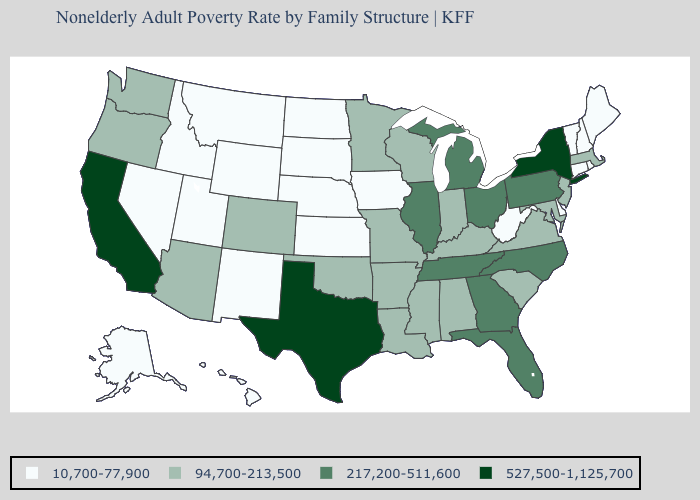Is the legend a continuous bar?
Write a very short answer. No. Name the states that have a value in the range 94,700-213,500?
Give a very brief answer. Alabama, Arizona, Arkansas, Colorado, Indiana, Kentucky, Louisiana, Maryland, Massachusetts, Minnesota, Mississippi, Missouri, New Jersey, Oklahoma, Oregon, South Carolina, Virginia, Washington, Wisconsin. What is the value of Maryland?
Concise answer only. 94,700-213,500. Name the states that have a value in the range 527,500-1,125,700?
Be succinct. California, New York, Texas. Does Arizona have the same value as Texas?
Answer briefly. No. Name the states that have a value in the range 94,700-213,500?
Be succinct. Alabama, Arizona, Arkansas, Colorado, Indiana, Kentucky, Louisiana, Maryland, Massachusetts, Minnesota, Mississippi, Missouri, New Jersey, Oklahoma, Oregon, South Carolina, Virginia, Washington, Wisconsin. What is the value of New Mexico?
Be succinct. 10,700-77,900. Does North Dakota have the same value as New Mexico?
Short answer required. Yes. What is the value of Montana?
Write a very short answer. 10,700-77,900. Name the states that have a value in the range 94,700-213,500?
Keep it brief. Alabama, Arizona, Arkansas, Colorado, Indiana, Kentucky, Louisiana, Maryland, Massachusetts, Minnesota, Mississippi, Missouri, New Jersey, Oklahoma, Oregon, South Carolina, Virginia, Washington, Wisconsin. Among the states that border New Mexico , which have the lowest value?
Be succinct. Utah. Does Nebraska have a lower value than Mississippi?
Give a very brief answer. Yes. Name the states that have a value in the range 527,500-1,125,700?
Give a very brief answer. California, New York, Texas. What is the value of Rhode Island?
Give a very brief answer. 10,700-77,900. Among the states that border Tennessee , does Alabama have the highest value?
Write a very short answer. No. 